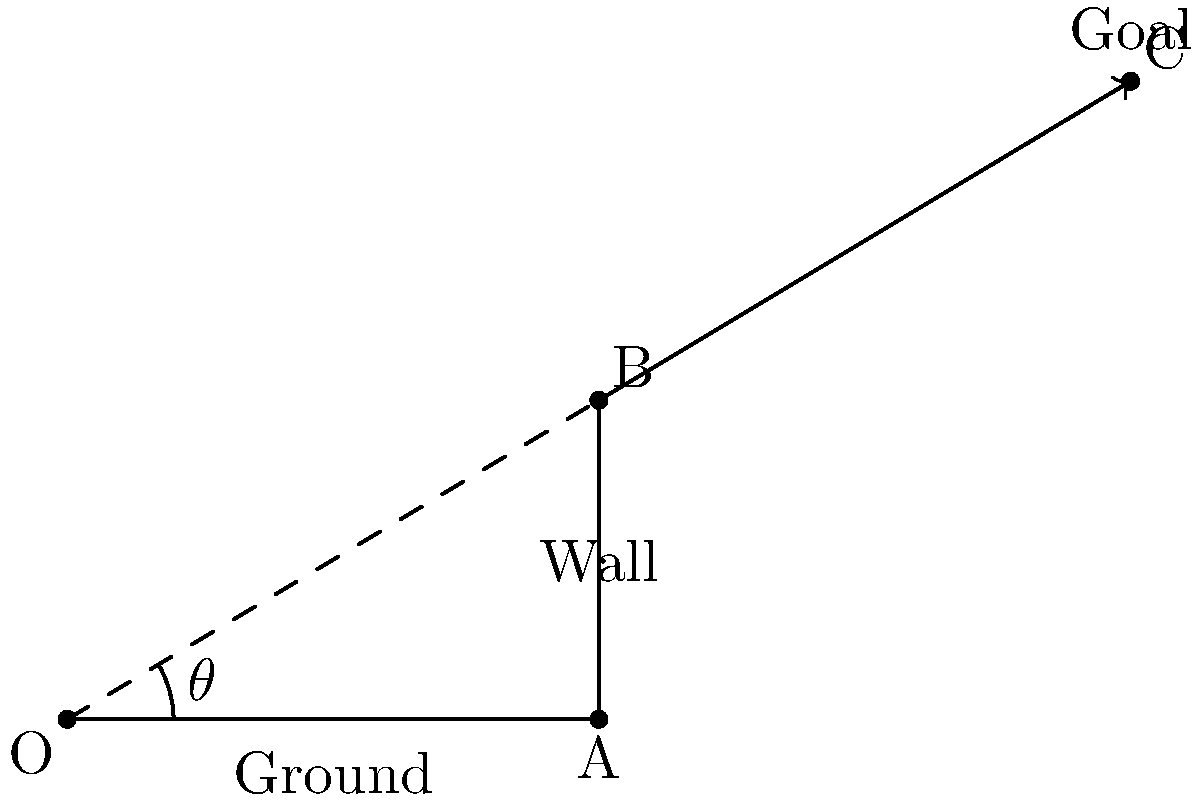You're coaching your son's soccer team in the big tournament. During practice, you want to help your star player improve his goal kicks over the defensive wall. The wall is 5 yards away and 3 yards tall. The goal is 10 yards away and 6 yards high. What is the minimum angle $\theta$ (in degrees, rounded to the nearest whole number) at which your player should kick the ball to clear the wall and hit the top corner of the goal? Let's approach this step-by-step:

1) We can treat this as a right triangle problem. The kick forms the hypotenuse of a right triangle.

2) We need to find the angle that just clears the wall and reaches the top corner of the goal.

3) We can use the tangent function to find this angle:

   $$\tan(\theta) = \frac{\text{opposite}}{\text{adjacent}}$$

4) The opposite side is the height difference between the goal and the wall: 6 - 3 = 3 yards

5) The adjacent side is the distance from the wall to the goal: 10 - 5 = 5 yards

6) Plugging these into our tangent function:

   $$\tan(\theta) = \frac{3}{5}$$

7) To find $\theta$, we need to use the inverse tangent (arctangent) function:

   $$\theta = \arctan(\frac{3}{5})$$

8) Using a calculator or computer:

   $$\theta \approx 30.96^\circ$$

9) Rounding to the nearest whole number:

   $$\theta \approx 31^\circ$$

Therefore, the minimum angle at which the player should kick the ball is approximately 31 degrees.
Answer: 31° 